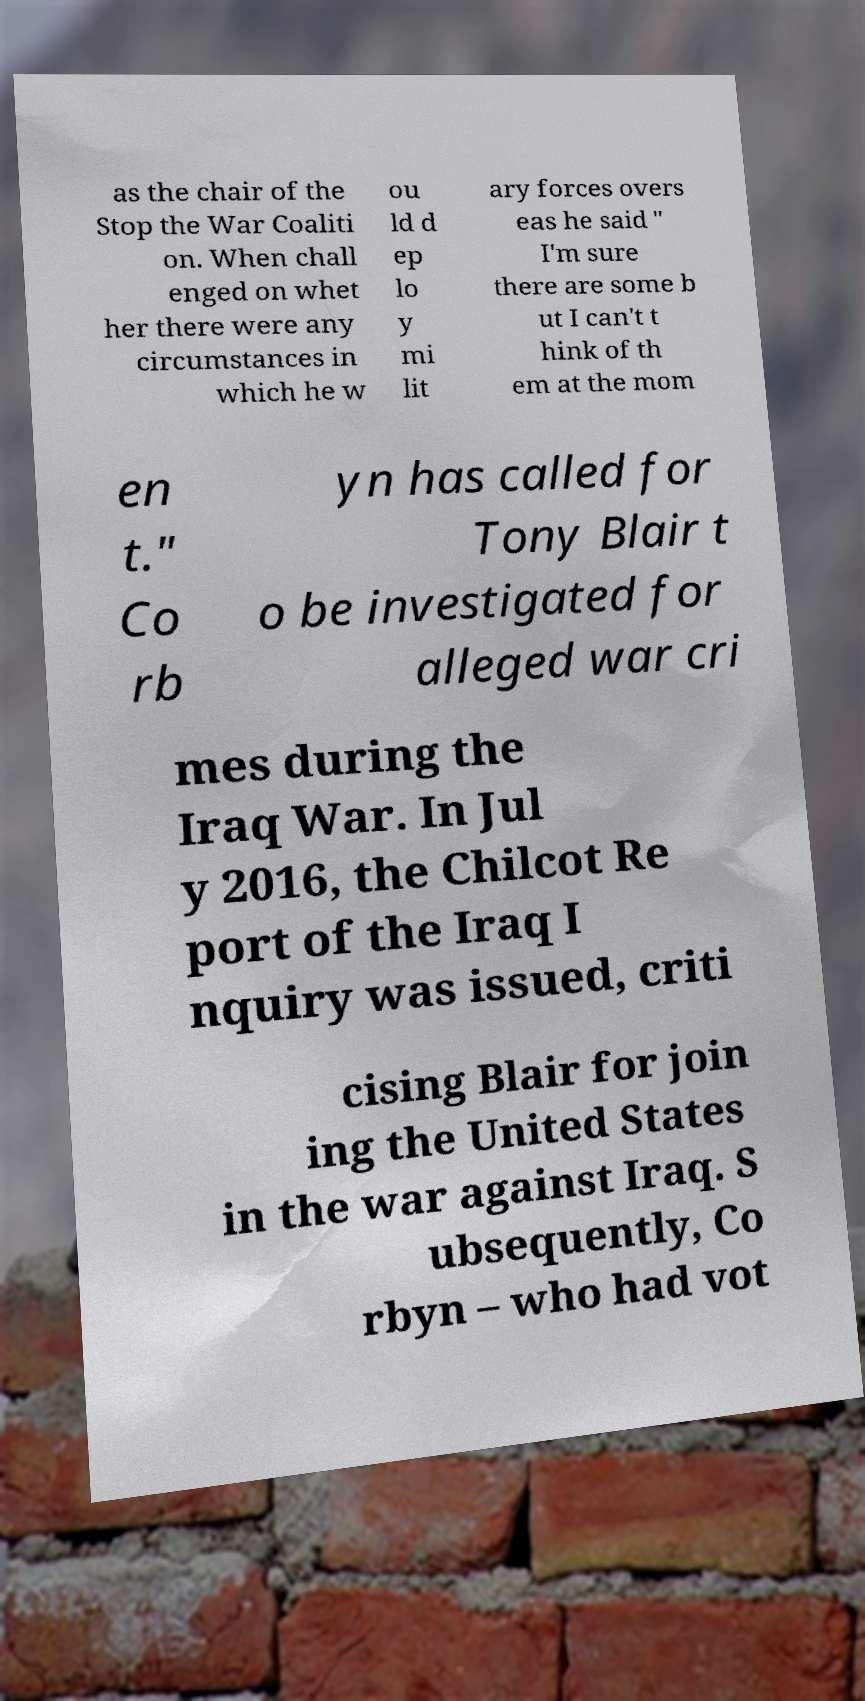Please read and relay the text visible in this image. What does it say? as the chair of the Stop the War Coaliti on. When chall enged on whet her there were any circumstances in which he w ou ld d ep lo y mi lit ary forces overs eas he said " I'm sure there are some b ut I can't t hink of th em at the mom en t." Co rb yn has called for Tony Blair t o be investigated for alleged war cri mes during the Iraq War. In Jul y 2016, the Chilcot Re port of the Iraq I nquiry was issued, criti cising Blair for join ing the United States in the war against Iraq. S ubsequently, Co rbyn – who had vot 